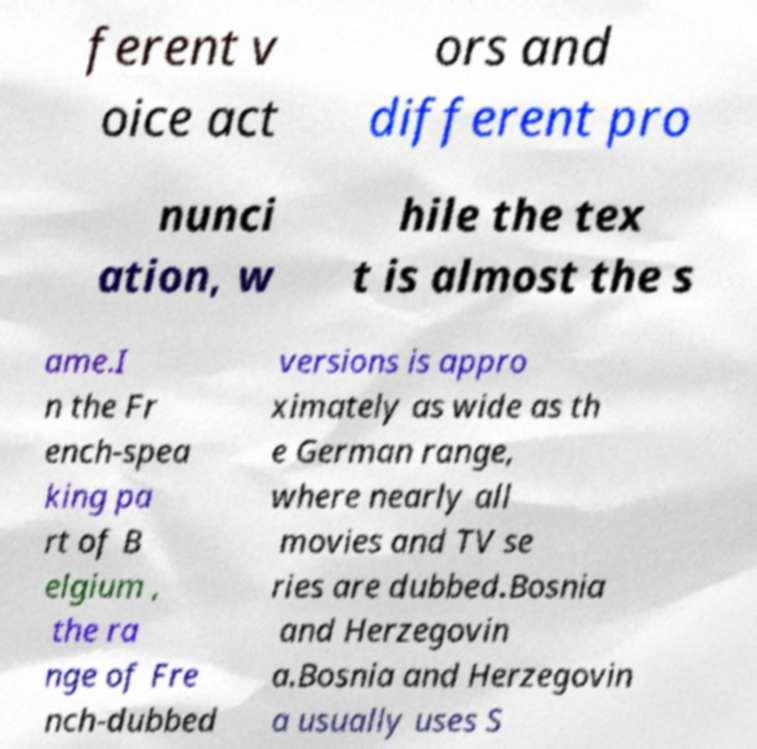What messages or text are displayed in this image? I need them in a readable, typed format. ferent v oice act ors and different pro nunci ation, w hile the tex t is almost the s ame.I n the Fr ench-spea king pa rt of B elgium , the ra nge of Fre nch-dubbed versions is appro ximately as wide as th e German range, where nearly all movies and TV se ries are dubbed.Bosnia and Herzegovin a.Bosnia and Herzegovin a usually uses S 